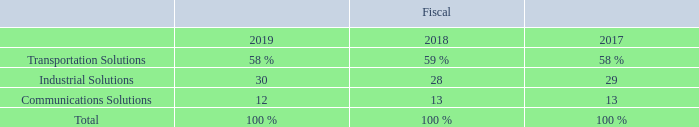Segments
We operate through three reportable segments: Transportation Solutions, Industrial Solutions, and Communications Solutions. We believe our segments serve a combined market of approximately $190 billion.
Our net sales by segment as a percentage of our total net sales were as follows:
Below is a description of our reportable segments and the primary products, markets, and competitors of each segment.
Transportation Solutions The Transportation Solutions segment is a leader in connectivity and sensor technologies. The primary products sold by the Transportation Solutions segment include terminals and connector systems and components, sensors, antennas, relays, application tooling, and wire and heat shrink tubing. The Transportation Solutions segment’s products, which must withstand harsh conditions, are used in the following end markets:
• Automotive (73% of segment’s net sales)—We are one of the leading providers of advanced automobile connectivity solutions. The automotive industry uses our products in automotive technologies for body and chassis systems, convenience applications, driver information, infotainment solutions, miniaturization solutions, motor and powertrain applications, and safety and security systems. Hybrid and electronic mobility solutions include in-vehicle technologies, battery technologies, and charging solutions.
• Commercial transportation (15% of segment’s net sales)—We deliver reliable connectivity products designed to withstand harsh environmental conditions for on- and off-highway vehicles and recreational transportation, including heavy trucks, construction, agriculture, buses, and other vehicles.
• Sensors (12% of segment’s net sales)—We offer a portfolio of intelligent, efficient, and high-performing sensor solutions that are used by customers across multiple industries, including automotive, industrial equipment, commercial transportation, medical solutions, aerospace and defense, and consumer applications.
The Transportation Solutions segment’s major competitors include Yazaki, Aptiv, Sumitomo, Sensata, Honeywell, Molex, and Amphenol.
Industrial Solutions The Industrial Solutions segment is a leading supplier of products that connect and distribute power, data, and signals. The primary products sold by the Industrial Solutions segment include terminals and connector systems and components, heat shrink tubing, relays, and wire and cable. The Industrial Solutions segment’s products are used in the following end markets:
• Industrial equipment (49% of segment’s net sales)—Our products are used in factory automation and process control systems such as industrial controls, robotics, human machine interface, industrial communication, and power distribution. Our intelligent building products are used to connect lighting, HVAC, elevators/escalators, and security. Our rail products are used in high-speed trains, metros, light rail vehicles, locomotives, and signaling switching equipment. Our products are also used by the solar industry. The medical industry uses our products in imaging, diagnostic, surgical, and minimally invasive interventional applications.
• Aerospace, defense, oil, and gas (33% of segment’s net sales)—We design, develop, and manufacture a comprehensive portfolio of critical electronic components and systems for the harsh operating conditions of the aerospace, defense, and marine industries. Our products and systems are designed and manufactured to operate effectively in harsh conditions ranging from the depths of the ocean to the far reaches of space.
• Energy (18% of segment’s net sales)—Our products are used by OEMs and utility companies in the electrical power industry and include a wide range of solutions for the electrical power generation, transmission, distribution, and industrial markets.
The Industrial Solutions segment competes primarily against Amphenol, Belden, Hubbell, Carlisle Companies, 3M, Integer Holdings, Esterline, Molex, and Phoenix Contact.
Communications Solutions The Communications Solutions segment is a leading supplier of electronic components for the data and devices and the appliances markets. The primary products sold by the Communications Solutions segment include terminals and connector systems and components, relays, heat shrink tubing, and antennas. The Communications Solutions segment’s products are used in the following end markets:
• Data and devices (59% of segment’s net sales)—We deliver products and solutions that are used in a variety of equipment architectures within the networking equipment, data center equipment, and wireless infrastructure industries. Additionally, we deliver a range of connectivity solutions for the Internet of Things, smartphones, tablet computers, notebooks, and virtual reality applications to help our customers meet their current challenges and future innovations.
• Appliances (41% of segment’s net sales)—We provide solutions to meet the daily demands of home appliances. Our products are used in many household appliances, including washers, dryers, refrigerators, air conditioners, dishwashers, cooking appliances, water heaters, air purifiers, floor care devices, and microwaves. Our expansive range of standard products is supplemented by an array of custom-designed solutions.
The Communications Solutions segment’s major competitors include Amphenol, Molex, JST, and Korea Electric Terminal (KET).
What are the net sales by segment presented as a percentage of? Percentage of our total net sales. How much does the company believe the Transportation, Industrial and Communications Solutions segments serve a combined market of? Approximately $190 billion. What are the three main segments that the company operates in? Transportation solutions, industrial solutions, communications solutions. In which year was the percentage of industrial solutions the lowest in? 28%<29%<30%
Answer: 2018. What was the percentage change in Industrial Solutions in 2019 from 2018?
Answer scale should be: percent. 30-28
Answer: 2. What was the percentage change in Transportation Solutions in 2019 from 2018?
Answer scale should be: percent. 58-59
Answer: -1. 